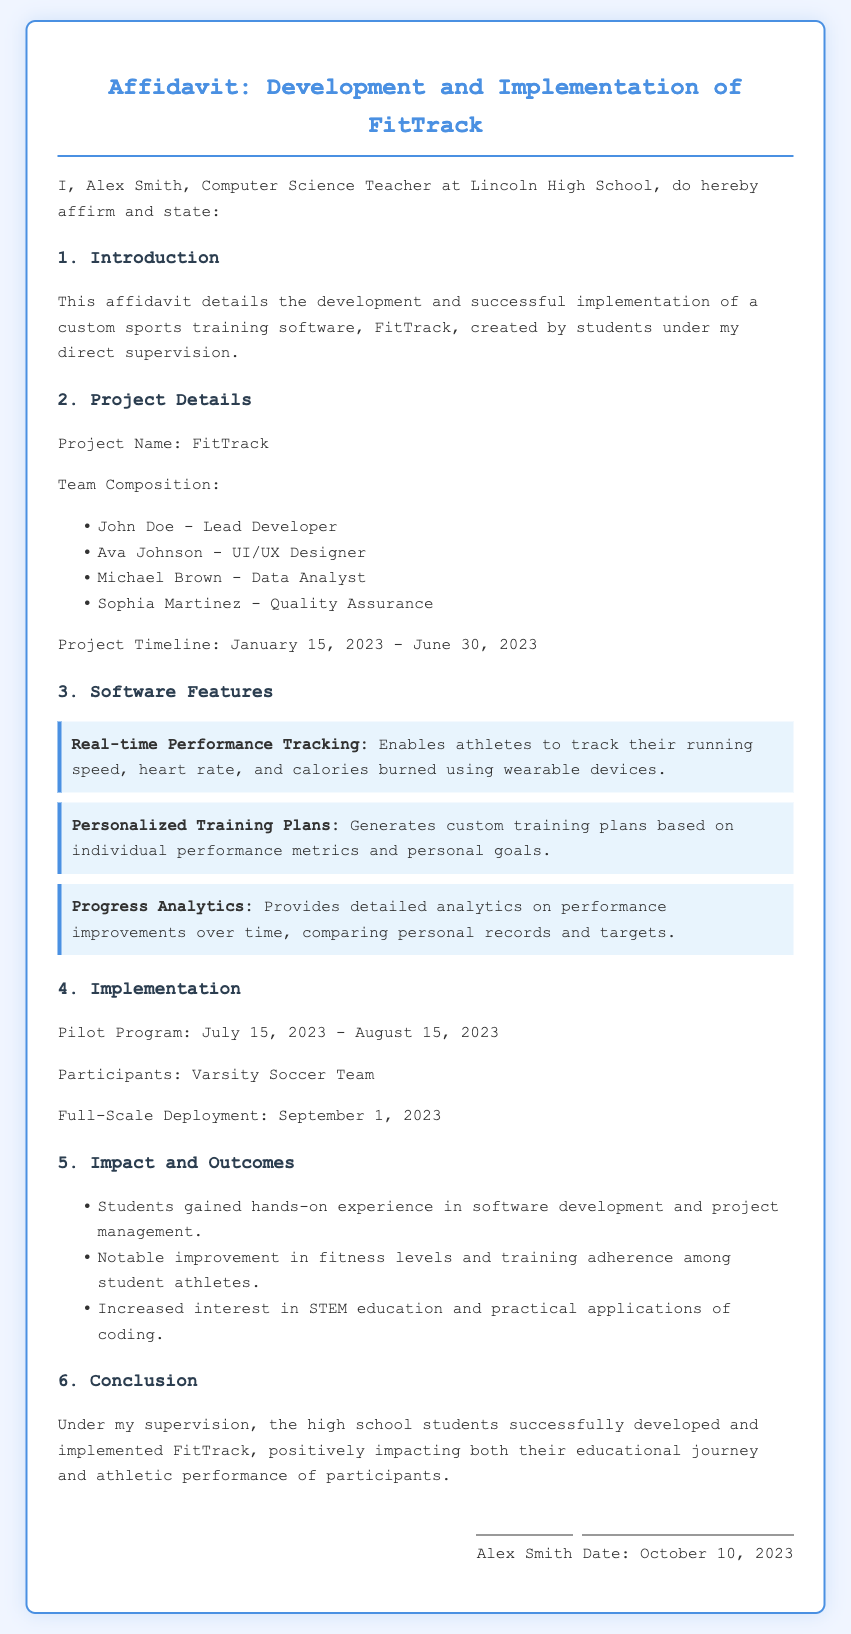What is the project name? The project name is clearly stated in the document under Project Details.
Answer: FitTrack Who is the lead developer? The lead developer is introduced in the Team Composition section of the document.
Answer: John Doe What is the start date of the project? The project timeline provides the start date for the development.
Answer: January 15, 2023 Which team participated in the pilot program? The section on Implementation specifies the participants of the pilot program.
Answer: Varsity Soccer Team How many software features are listed? The software features section enumerates the features provided.
Answer: Three What was the full-scale deployment date? The full-scale deployment date is noted under Implementation.
Answer: September 1, 2023 Who supervises the project? The introduction mentions who is affirming the details about the project.
Answer: Alex Smith What is one outcome mentioned for the students? The Impact and Outcomes section mentions the gains for the students.
Answer: Hands-on experience 